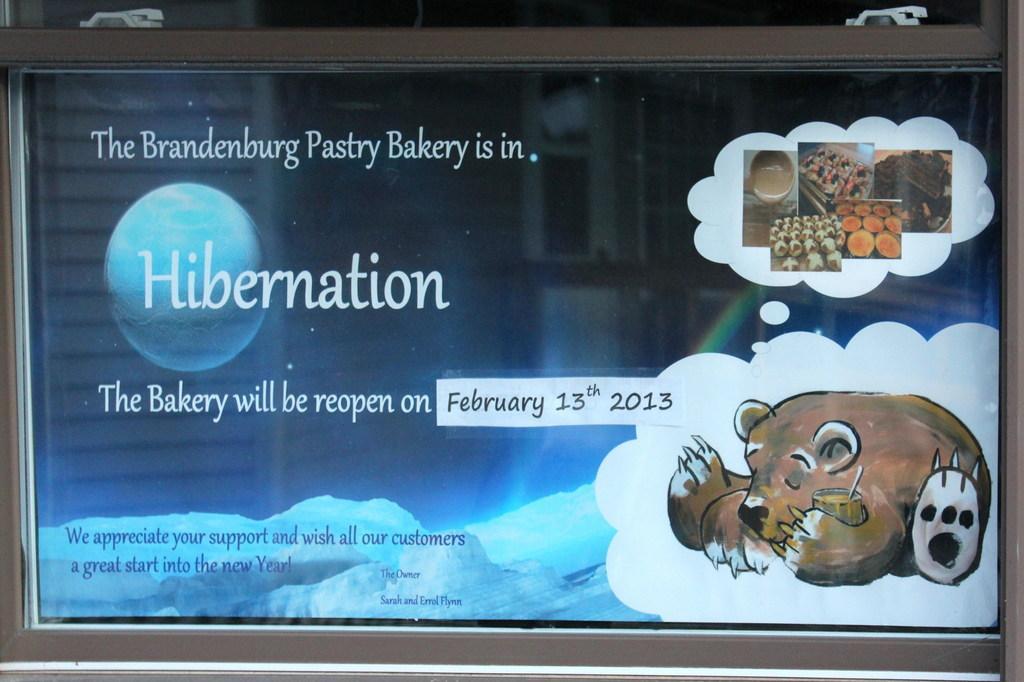Please provide a concise description of this image. This image consists of a screen. On the screen I can see some text and images of an animal and some food items. 